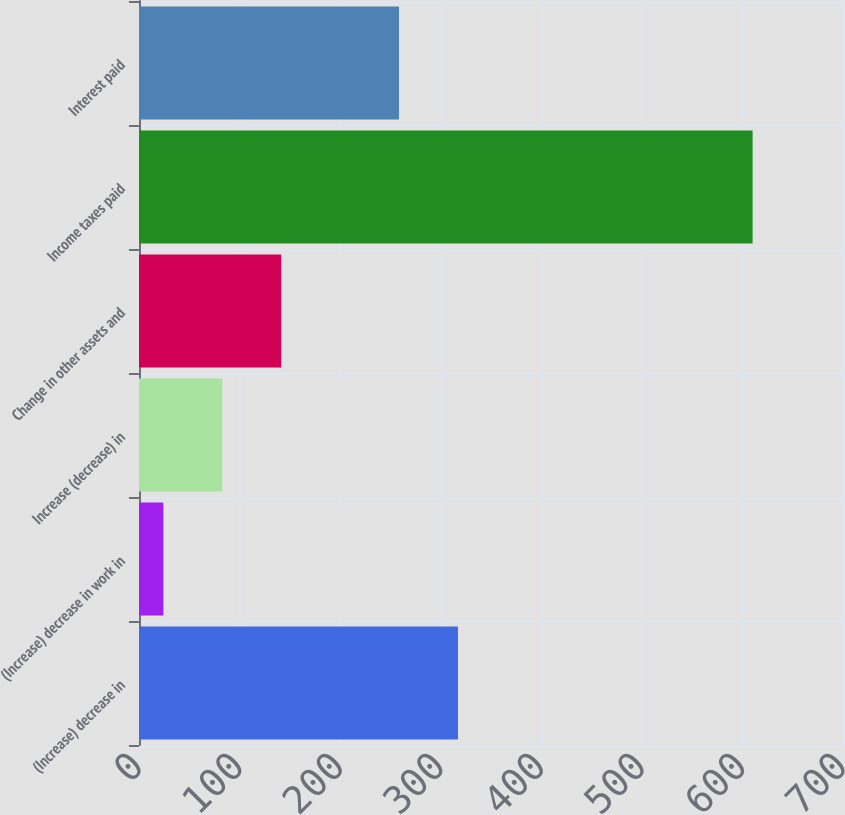<chart> <loc_0><loc_0><loc_500><loc_500><bar_chart><fcel>(Increase) decrease in<fcel>(Increase) decrease in work in<fcel>Increase (decrease) in<fcel>Change in other assets and<fcel>Income taxes paid<fcel>Interest paid<nl><fcel>317.15<fcel>24.2<fcel>82.79<fcel>141.38<fcel>610.1<fcel>258.56<nl></chart> 